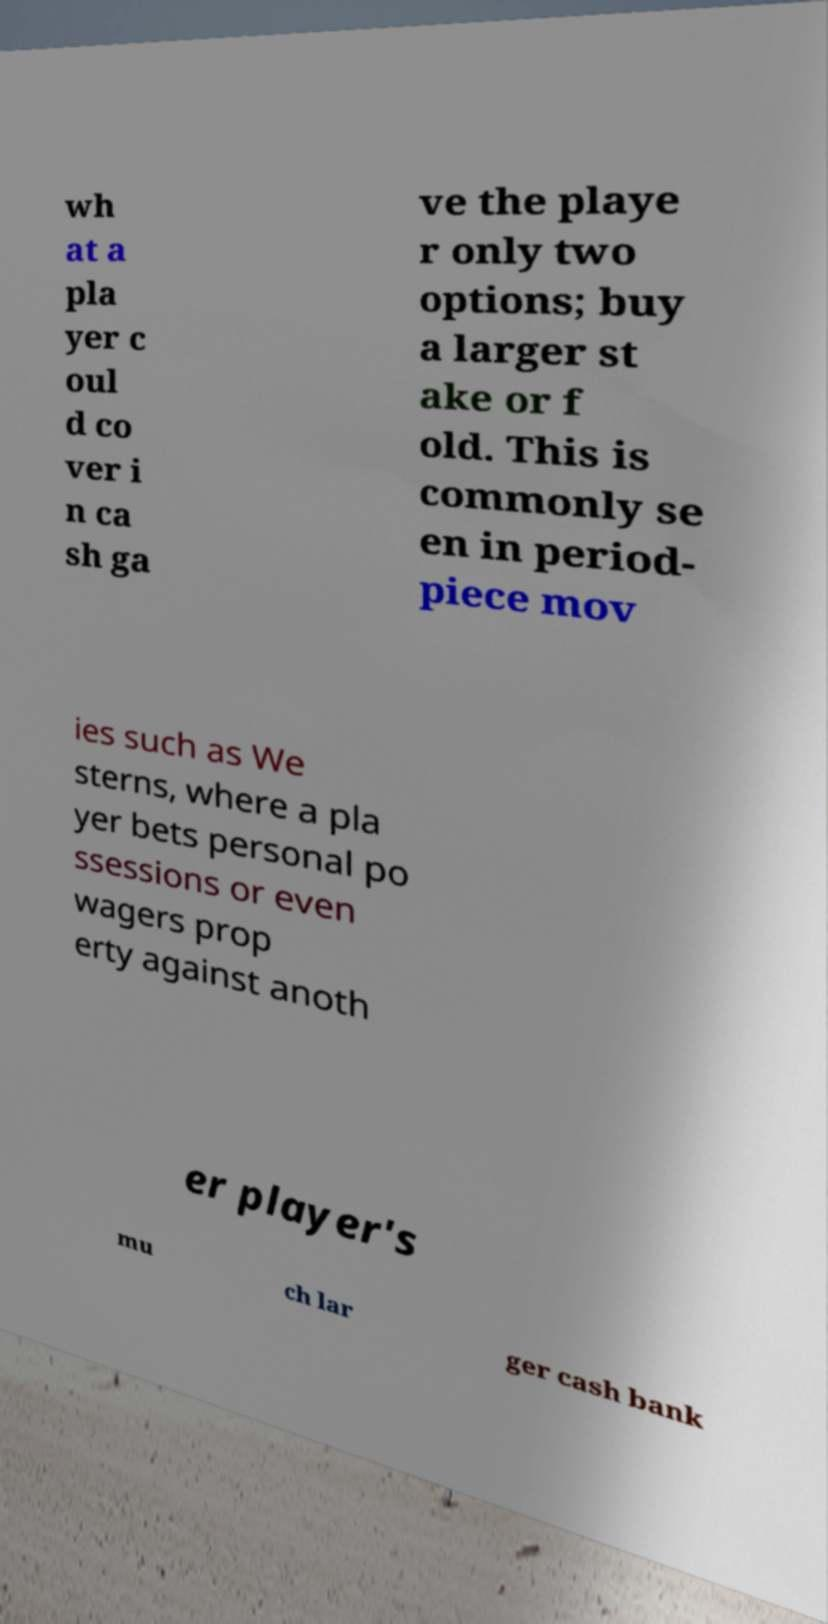For documentation purposes, I need the text within this image transcribed. Could you provide that? wh at a pla yer c oul d co ver i n ca sh ga ve the playe r only two options; buy a larger st ake or f old. This is commonly se en in period- piece mov ies such as We sterns, where a pla yer bets personal po ssessions or even wagers prop erty against anoth er player's mu ch lar ger cash bank 